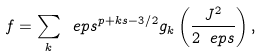<formula> <loc_0><loc_0><loc_500><loc_500>f = \sum _ { k } \ e p s ^ { p + k s - 3 / 2 } g _ { k } \left ( \frac { J ^ { 2 } } { 2 \ e p s } \right ) ,</formula> 